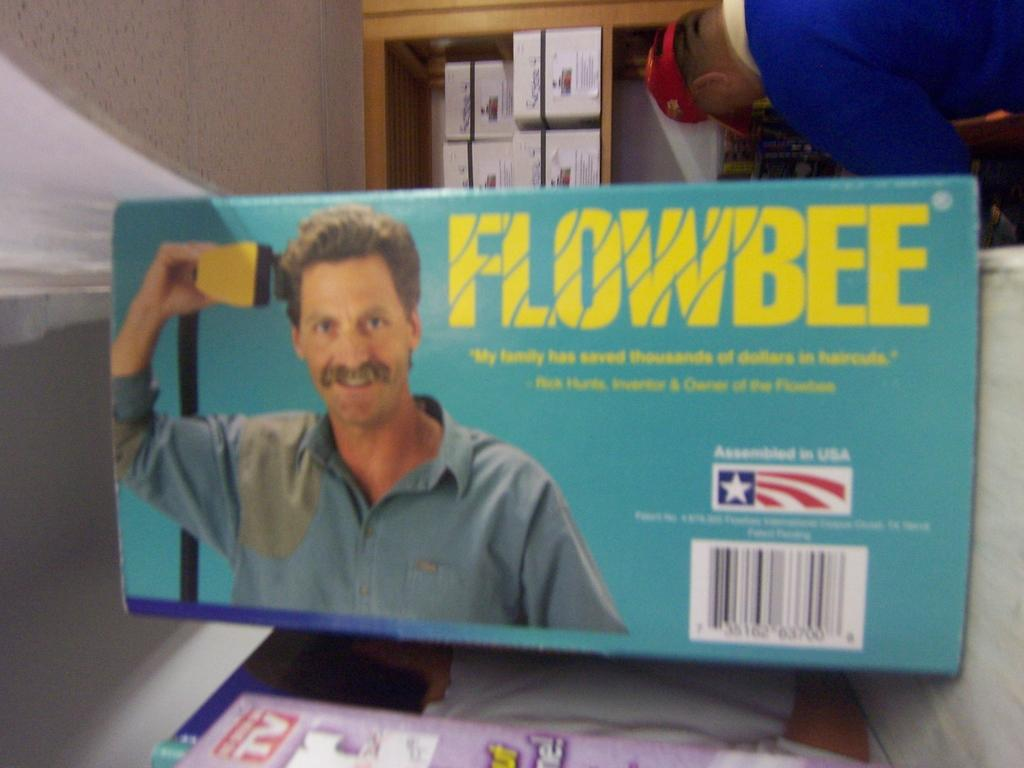What is on the table in the image? There is a box on the table in the image. What is written on the box? The box has "Flowbee" written on it. Who is standing behind the table in the image? There is a man standing behind the table in the image. What is the man wearing on his head? The man is wearing a cap. What else can be seen in the image besides the box on the table? There are boxes in a rack in the image. What type of club does the man use to hit the oatmeal in the image? There is no club or oatmeal present in the image. 